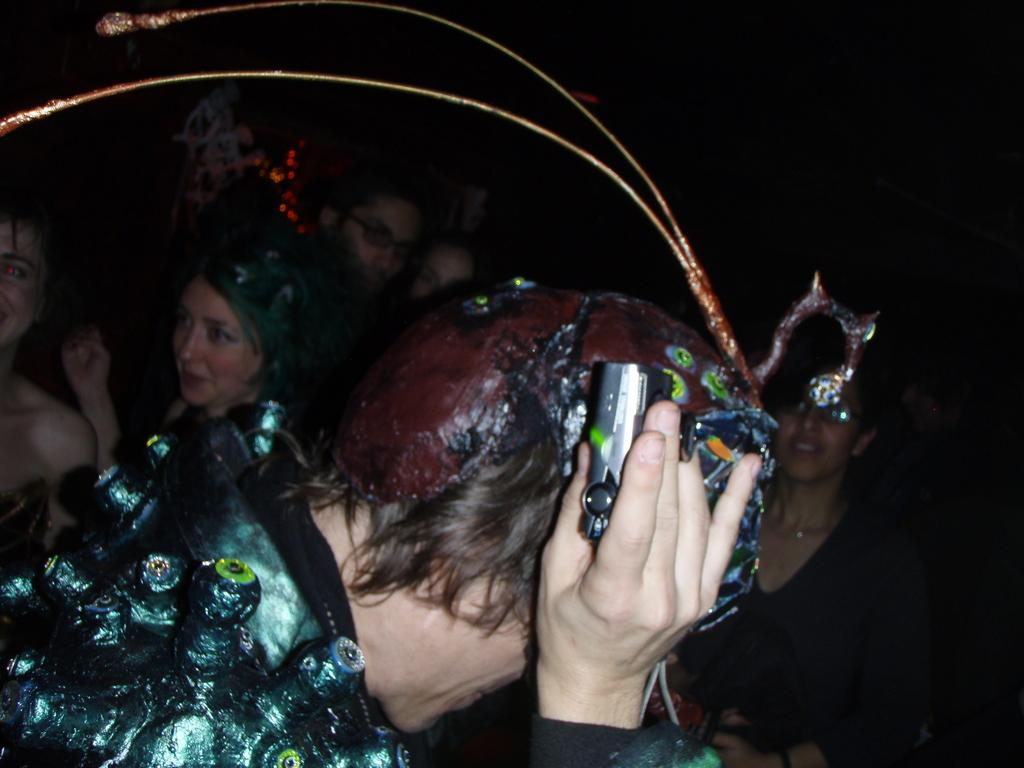What is happening in the image? There are people standing in the image. Can you describe what one of the people is doing? There is a person holding a camera in their hand. What can be observed about the background of the image? The background of the image is completely dark. What type of soap is being used by the person holding the camera in the image? There is no soap present in the image, as it features people standing and one person holding a camera. 